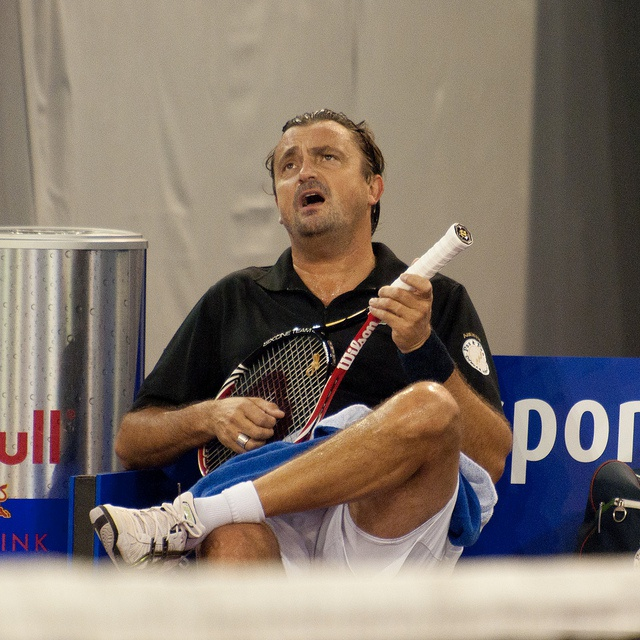Describe the objects in this image and their specific colors. I can see people in gray, black, maroon, and brown tones, bench in gray, navy, black, darkblue, and lightgray tones, tennis racket in gray, black, beige, and tan tones, and handbag in gray, black, and tan tones in this image. 